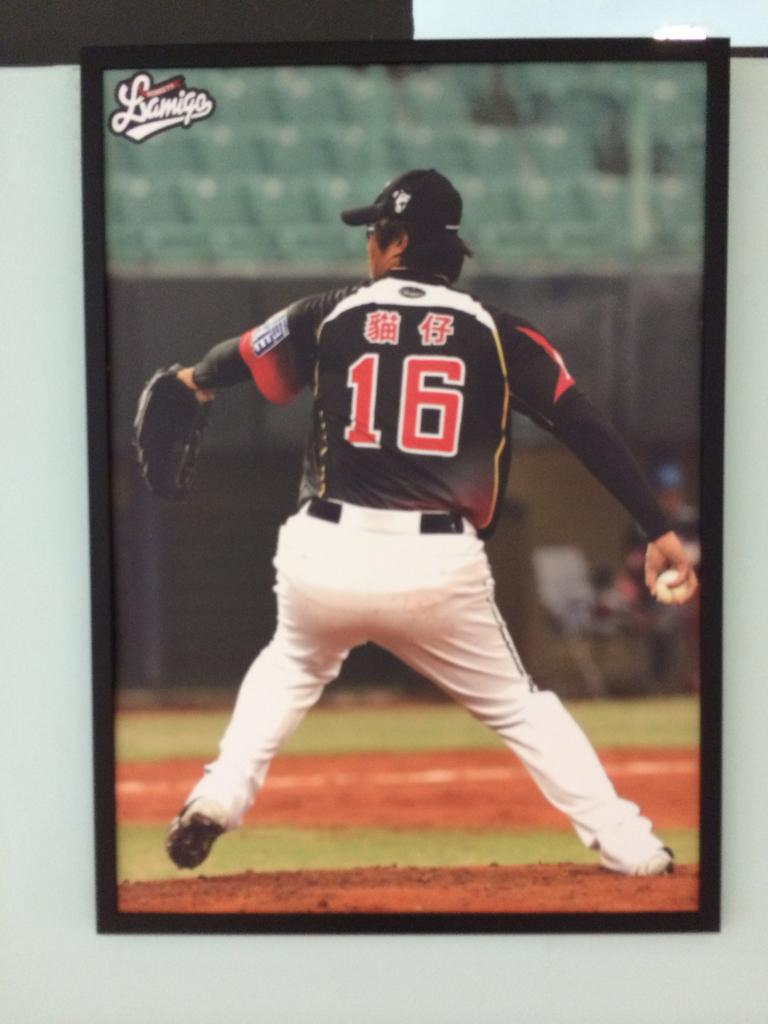<image>
Describe the image concisely. A baseball pitcher with the number 16 winds up a pitch. 